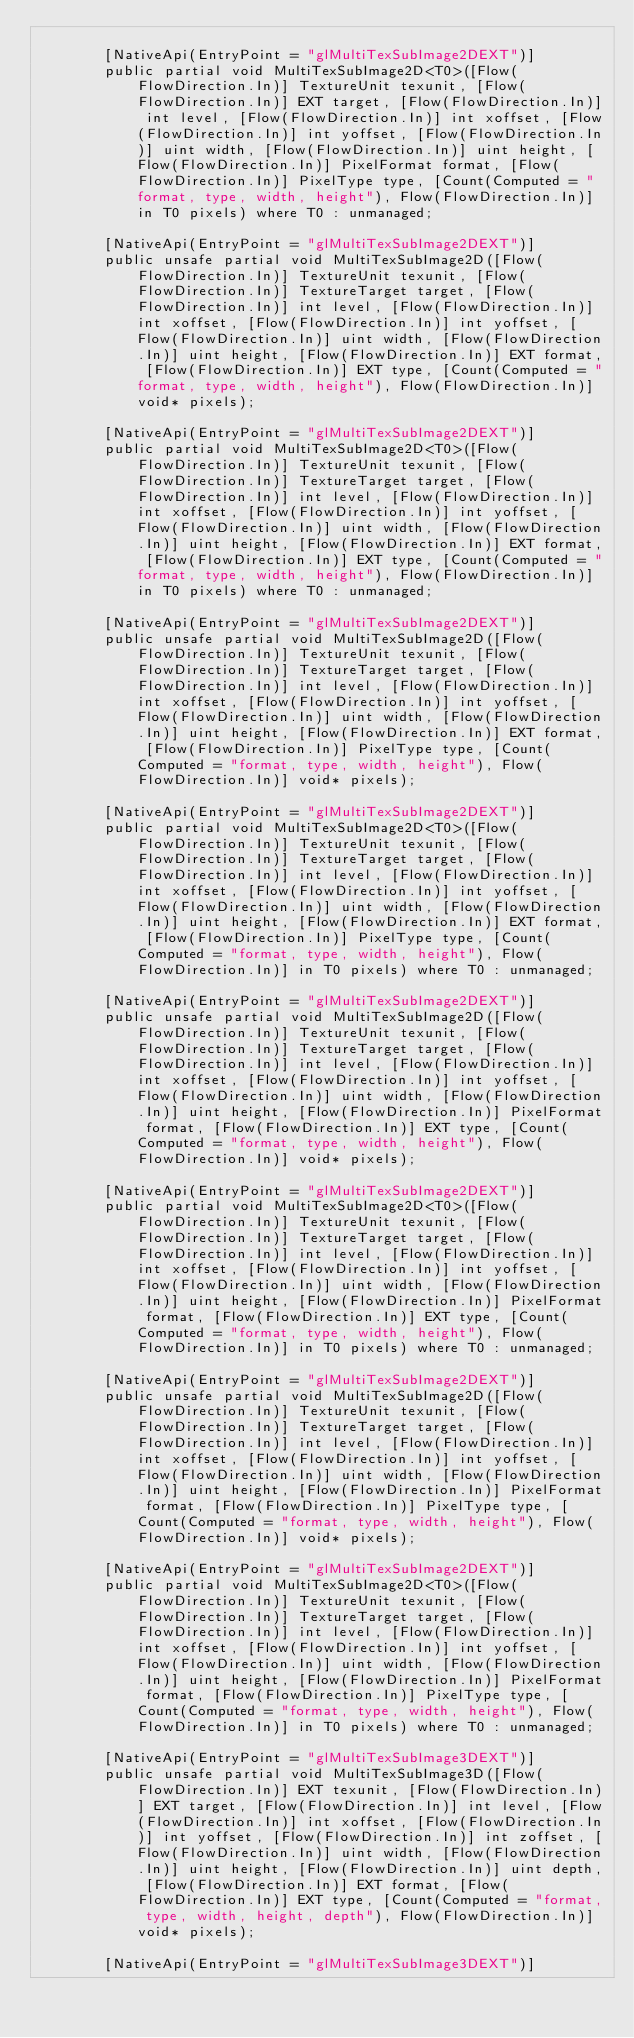<code> <loc_0><loc_0><loc_500><loc_500><_C#_>
        [NativeApi(EntryPoint = "glMultiTexSubImage2DEXT")]
        public partial void MultiTexSubImage2D<T0>([Flow(FlowDirection.In)] TextureUnit texunit, [Flow(FlowDirection.In)] EXT target, [Flow(FlowDirection.In)] int level, [Flow(FlowDirection.In)] int xoffset, [Flow(FlowDirection.In)] int yoffset, [Flow(FlowDirection.In)] uint width, [Flow(FlowDirection.In)] uint height, [Flow(FlowDirection.In)] PixelFormat format, [Flow(FlowDirection.In)] PixelType type, [Count(Computed = "format, type, width, height"), Flow(FlowDirection.In)] in T0 pixels) where T0 : unmanaged;

        [NativeApi(EntryPoint = "glMultiTexSubImage2DEXT")]
        public unsafe partial void MultiTexSubImage2D([Flow(FlowDirection.In)] TextureUnit texunit, [Flow(FlowDirection.In)] TextureTarget target, [Flow(FlowDirection.In)] int level, [Flow(FlowDirection.In)] int xoffset, [Flow(FlowDirection.In)] int yoffset, [Flow(FlowDirection.In)] uint width, [Flow(FlowDirection.In)] uint height, [Flow(FlowDirection.In)] EXT format, [Flow(FlowDirection.In)] EXT type, [Count(Computed = "format, type, width, height"), Flow(FlowDirection.In)] void* pixels);

        [NativeApi(EntryPoint = "glMultiTexSubImage2DEXT")]
        public partial void MultiTexSubImage2D<T0>([Flow(FlowDirection.In)] TextureUnit texunit, [Flow(FlowDirection.In)] TextureTarget target, [Flow(FlowDirection.In)] int level, [Flow(FlowDirection.In)] int xoffset, [Flow(FlowDirection.In)] int yoffset, [Flow(FlowDirection.In)] uint width, [Flow(FlowDirection.In)] uint height, [Flow(FlowDirection.In)] EXT format, [Flow(FlowDirection.In)] EXT type, [Count(Computed = "format, type, width, height"), Flow(FlowDirection.In)] in T0 pixels) where T0 : unmanaged;

        [NativeApi(EntryPoint = "glMultiTexSubImage2DEXT")]
        public unsafe partial void MultiTexSubImage2D([Flow(FlowDirection.In)] TextureUnit texunit, [Flow(FlowDirection.In)] TextureTarget target, [Flow(FlowDirection.In)] int level, [Flow(FlowDirection.In)] int xoffset, [Flow(FlowDirection.In)] int yoffset, [Flow(FlowDirection.In)] uint width, [Flow(FlowDirection.In)] uint height, [Flow(FlowDirection.In)] EXT format, [Flow(FlowDirection.In)] PixelType type, [Count(Computed = "format, type, width, height"), Flow(FlowDirection.In)] void* pixels);

        [NativeApi(EntryPoint = "glMultiTexSubImage2DEXT")]
        public partial void MultiTexSubImage2D<T0>([Flow(FlowDirection.In)] TextureUnit texunit, [Flow(FlowDirection.In)] TextureTarget target, [Flow(FlowDirection.In)] int level, [Flow(FlowDirection.In)] int xoffset, [Flow(FlowDirection.In)] int yoffset, [Flow(FlowDirection.In)] uint width, [Flow(FlowDirection.In)] uint height, [Flow(FlowDirection.In)] EXT format, [Flow(FlowDirection.In)] PixelType type, [Count(Computed = "format, type, width, height"), Flow(FlowDirection.In)] in T0 pixels) where T0 : unmanaged;

        [NativeApi(EntryPoint = "glMultiTexSubImage2DEXT")]
        public unsafe partial void MultiTexSubImage2D([Flow(FlowDirection.In)] TextureUnit texunit, [Flow(FlowDirection.In)] TextureTarget target, [Flow(FlowDirection.In)] int level, [Flow(FlowDirection.In)] int xoffset, [Flow(FlowDirection.In)] int yoffset, [Flow(FlowDirection.In)] uint width, [Flow(FlowDirection.In)] uint height, [Flow(FlowDirection.In)] PixelFormat format, [Flow(FlowDirection.In)] EXT type, [Count(Computed = "format, type, width, height"), Flow(FlowDirection.In)] void* pixels);

        [NativeApi(EntryPoint = "glMultiTexSubImage2DEXT")]
        public partial void MultiTexSubImage2D<T0>([Flow(FlowDirection.In)] TextureUnit texunit, [Flow(FlowDirection.In)] TextureTarget target, [Flow(FlowDirection.In)] int level, [Flow(FlowDirection.In)] int xoffset, [Flow(FlowDirection.In)] int yoffset, [Flow(FlowDirection.In)] uint width, [Flow(FlowDirection.In)] uint height, [Flow(FlowDirection.In)] PixelFormat format, [Flow(FlowDirection.In)] EXT type, [Count(Computed = "format, type, width, height"), Flow(FlowDirection.In)] in T0 pixels) where T0 : unmanaged;

        [NativeApi(EntryPoint = "glMultiTexSubImage2DEXT")]
        public unsafe partial void MultiTexSubImage2D([Flow(FlowDirection.In)] TextureUnit texunit, [Flow(FlowDirection.In)] TextureTarget target, [Flow(FlowDirection.In)] int level, [Flow(FlowDirection.In)] int xoffset, [Flow(FlowDirection.In)] int yoffset, [Flow(FlowDirection.In)] uint width, [Flow(FlowDirection.In)] uint height, [Flow(FlowDirection.In)] PixelFormat format, [Flow(FlowDirection.In)] PixelType type, [Count(Computed = "format, type, width, height"), Flow(FlowDirection.In)] void* pixels);

        [NativeApi(EntryPoint = "glMultiTexSubImage2DEXT")]
        public partial void MultiTexSubImage2D<T0>([Flow(FlowDirection.In)] TextureUnit texunit, [Flow(FlowDirection.In)] TextureTarget target, [Flow(FlowDirection.In)] int level, [Flow(FlowDirection.In)] int xoffset, [Flow(FlowDirection.In)] int yoffset, [Flow(FlowDirection.In)] uint width, [Flow(FlowDirection.In)] uint height, [Flow(FlowDirection.In)] PixelFormat format, [Flow(FlowDirection.In)] PixelType type, [Count(Computed = "format, type, width, height"), Flow(FlowDirection.In)] in T0 pixels) where T0 : unmanaged;

        [NativeApi(EntryPoint = "glMultiTexSubImage3DEXT")]
        public unsafe partial void MultiTexSubImage3D([Flow(FlowDirection.In)] EXT texunit, [Flow(FlowDirection.In)] EXT target, [Flow(FlowDirection.In)] int level, [Flow(FlowDirection.In)] int xoffset, [Flow(FlowDirection.In)] int yoffset, [Flow(FlowDirection.In)] int zoffset, [Flow(FlowDirection.In)] uint width, [Flow(FlowDirection.In)] uint height, [Flow(FlowDirection.In)] uint depth, [Flow(FlowDirection.In)] EXT format, [Flow(FlowDirection.In)] EXT type, [Count(Computed = "format, type, width, height, depth"), Flow(FlowDirection.In)] void* pixels);

        [NativeApi(EntryPoint = "glMultiTexSubImage3DEXT")]</code> 